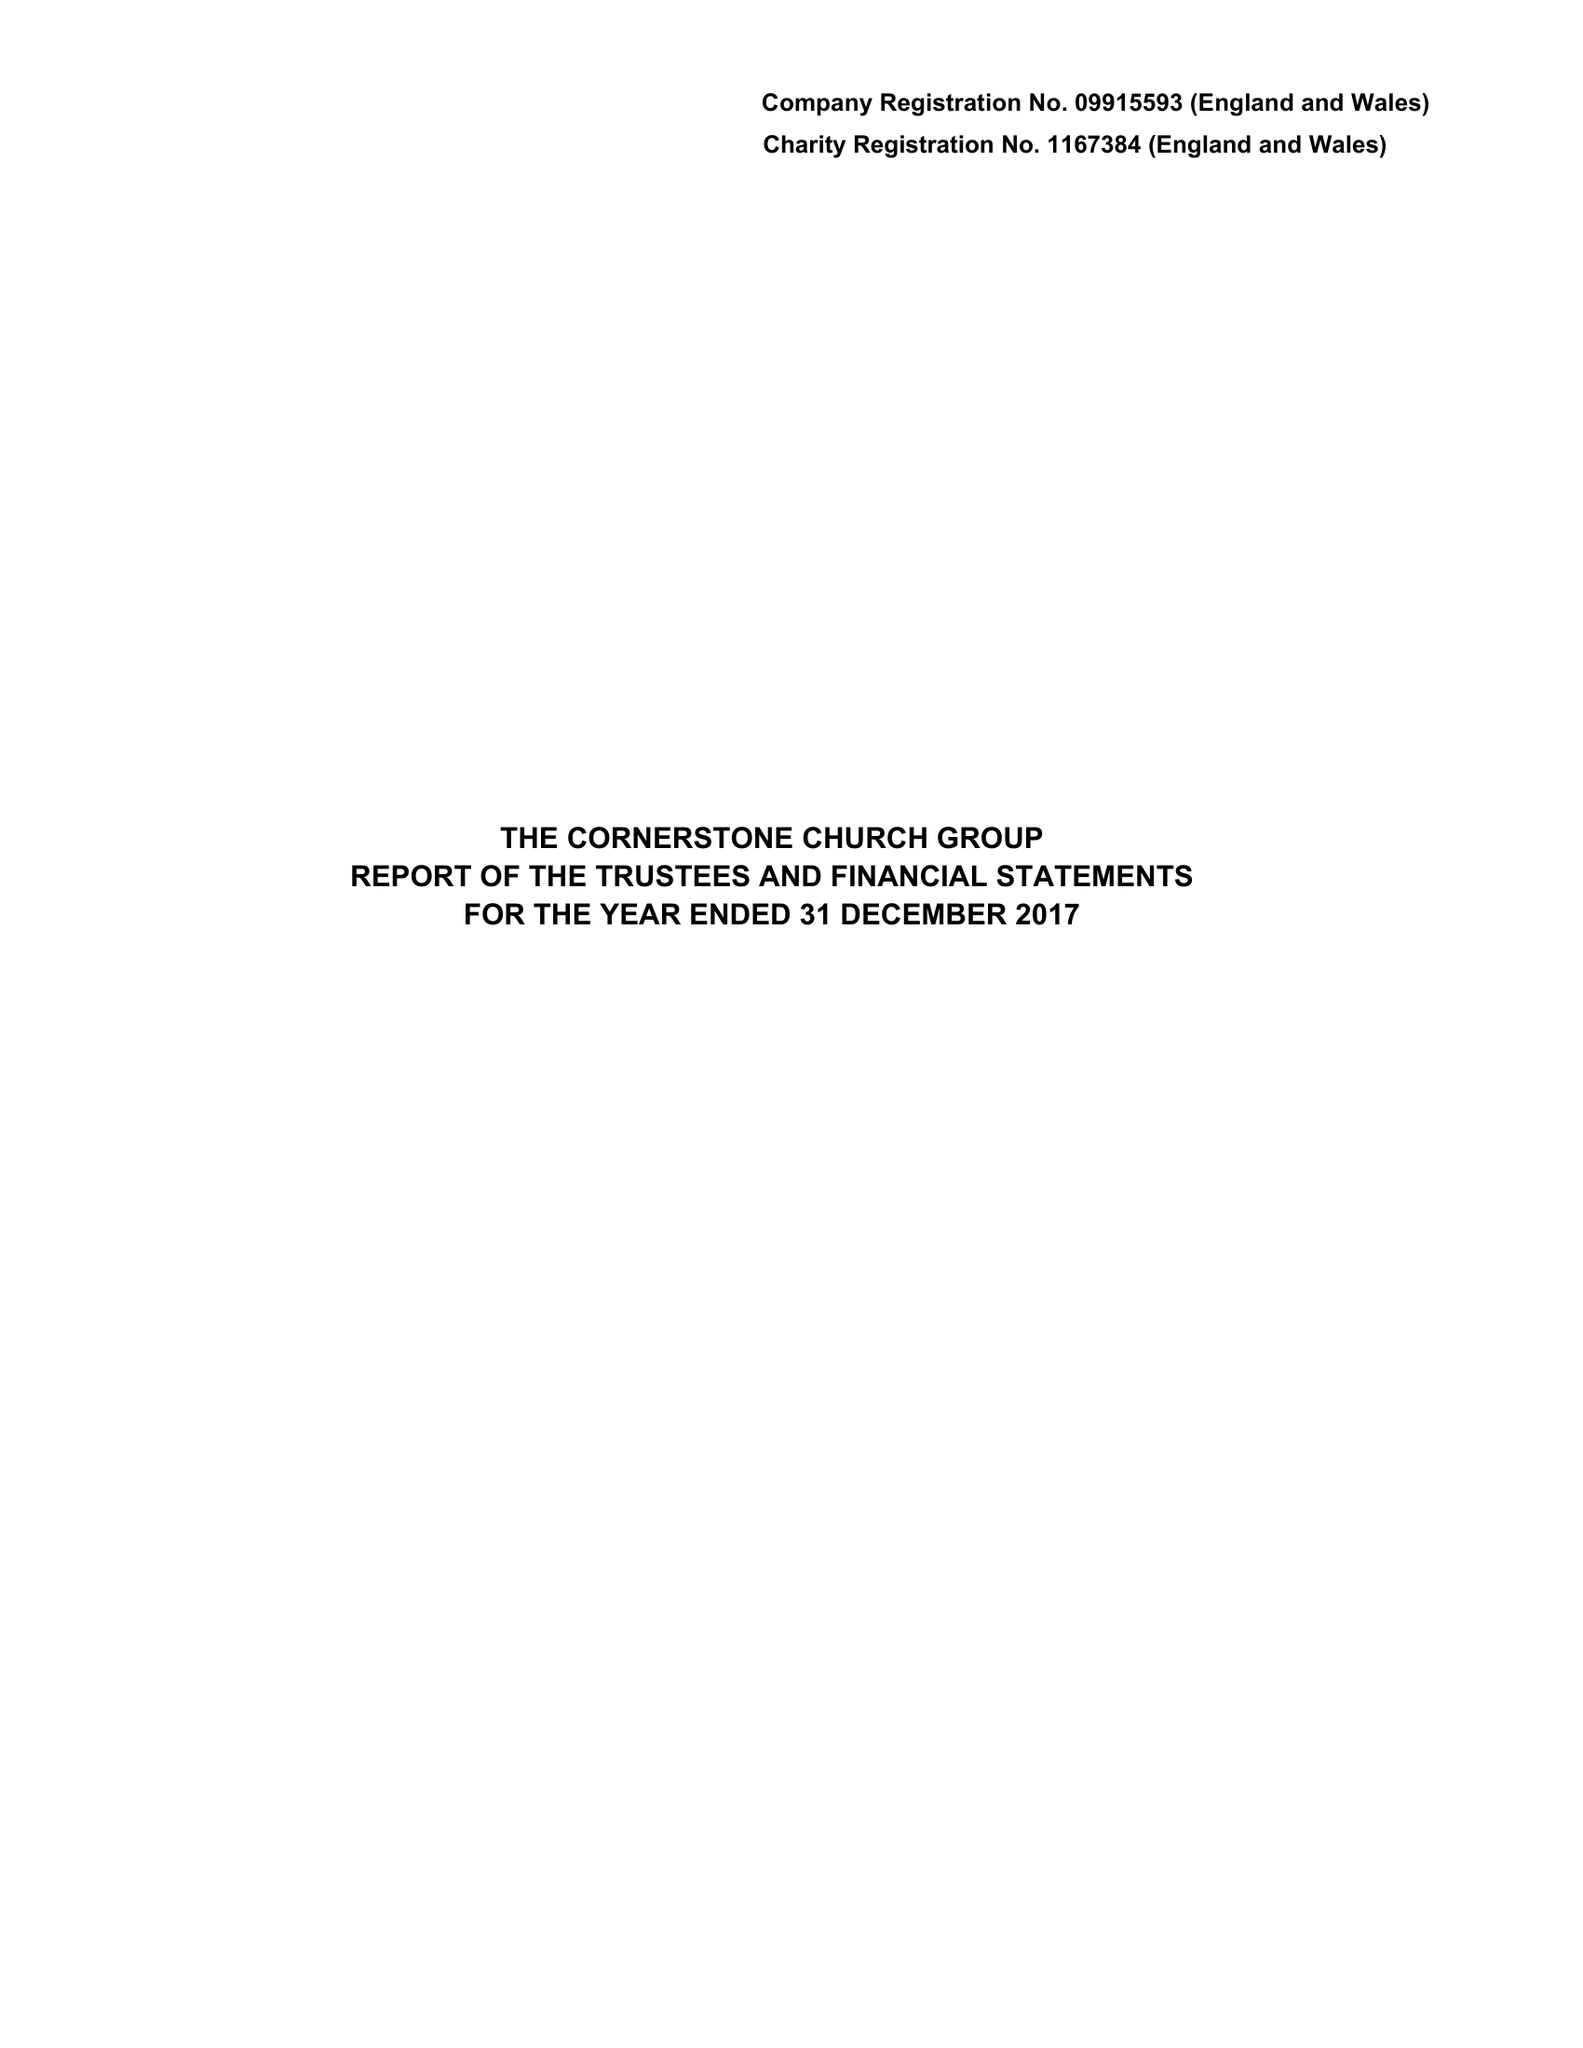What is the value for the report_date?
Answer the question using a single word or phrase. 2017-12-31 